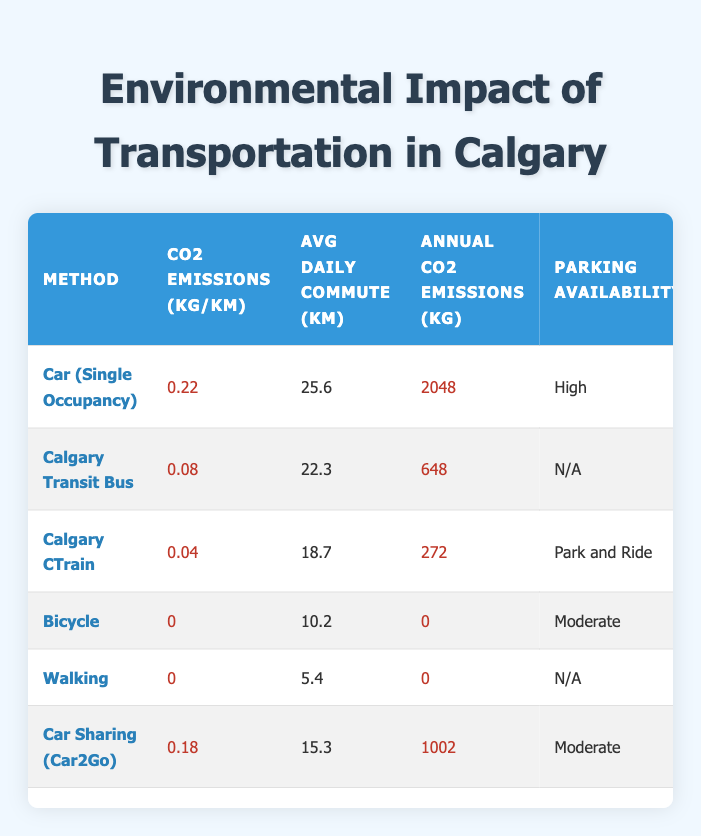What are the CO2 emissions per kilometer for the Calgary CTrain? From the table, the CO2 emissions per kilometer for the Calgary CTrain is directly stated as 0.04 kg/km.
Answer: 0.04 kg/km How much is the cost per kilometer for using a Bicycle? The table lists the cost per kilometer for a Bicycle as 0.05.
Answer: 0.05 What is the average daily commute distance for a Car (Single Occupancy)? The average daily commute distance for a Car (Single Occupancy) is found in the corresponding row and is 25.6 km.
Answer: 25.6 km Which transportation method has the lowest impact on air quality? Looking at the "Air Quality Impact" column, the Calgary CTrain has the lowest impact listed as "Low."
Answer: Calgary CTrain What is the total annual CO2 emissions from both Car Sharing (Car2Go) and Calgary Transit Bus? Adding the annual CO2 emissions for Car Sharing (Car2Go) which is 1002 kg and Calgary Transit Bus with 648 kg gives 1002 + 648 = 1650 kg.
Answer: 1650 kg Is the parking availability for Walking listed in the table? Referring to the table, the parking availability for Walking is listed as N/A, which means it does not apply.
Answer: No Which transportation method has the highest annual CO2 emissions? By reviewing the "Annual CO2 Emissions" column, the Car (Single Occupancy) has the highest emissions, noted as 2048 kg.
Answer: Car (Single Occupancy) What is the difference in annual CO2 emissions between Car (Single Occupancy) and Bicycle? The annual CO2 emissions for Car (Single Occupancy) is 2048 kg and for Bicycle it is 0 kg. The difference is 2048 - 0 = 2048 kg.
Answer: 2048 kg How many transportation methods listed have a noise level categorized as Moderate? The table shows that both Car (Single Occupancy) and Car Sharing (Car2Go) have a noise level categorized as Moderate, therefore there are 2 methods.
Answer: 2 